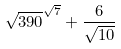<formula> <loc_0><loc_0><loc_500><loc_500>\sqrt { 3 9 0 } ^ { \sqrt { 7 } } + \frac { 6 } { \sqrt { 1 0 } }</formula> 